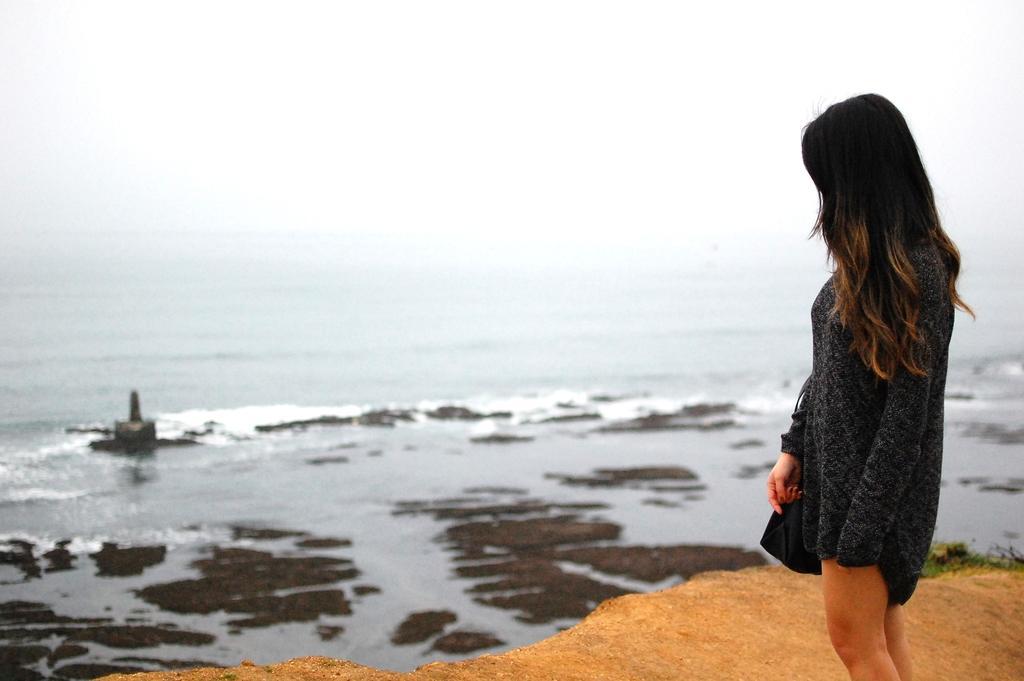Can you describe this image briefly? In this image I can see a woman wearing black color dress is standing on the ground. In the background I can see the ground, the water, a black colored object on the surface of the water and the sky. 